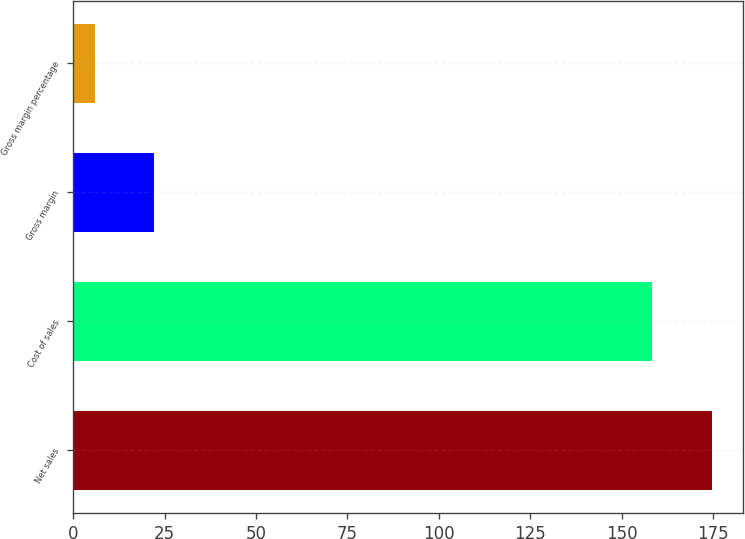Convert chart. <chart><loc_0><loc_0><loc_500><loc_500><bar_chart><fcel>Net sales<fcel>Cost of sales<fcel>Gross margin<fcel>Gross margin percentage<nl><fcel>174.54<fcel>158.3<fcel>22.24<fcel>6<nl></chart> 